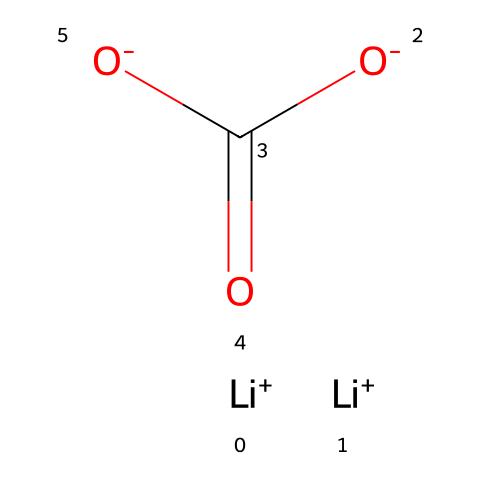What is the total number of atoms in lithium carbonate? The structure shows two lithium ions (Li+), one carbon atom (C), and three oxygen atoms (O), giving us a total of six atoms (2 from Li + 1 from C + 3 from O).
Answer: six How many lithium ions are present in lithium carbonate? The SMILES representation indicates two instances of Li+ at the start, confirming that there are two lithium ions.
Answer: two What is the charge of the carbonate ion in lithium carbonate? The SMILES shows two negatively charged oxygen atoms (O-) attached to a carbon atom (C) which forms a carbonate (CO3) unit, giving a total charge of -2 to the carbonate ion.
Answer: -2 How many double bonds are present in the molecule? The SMILES representation indicates one carbon is double-bonded to one oxygen atom (C=O), suggesting there is one double bond in the entire structure.
Answer: one What type of electrolyte is lithium carbonate categorized as? Lithium carbonate is categorized as a lithium salt, formed from lithium and carbonate ions, which is a common type of electrolyte.
Answer: lithium salt Does lithium carbonate contribute to mood stabilization? Lithium carbonate is known for its use in mood stabilizers, particularly in the treatment of bipolar disorder, indicating its contribution to mental health.
Answer: yes 